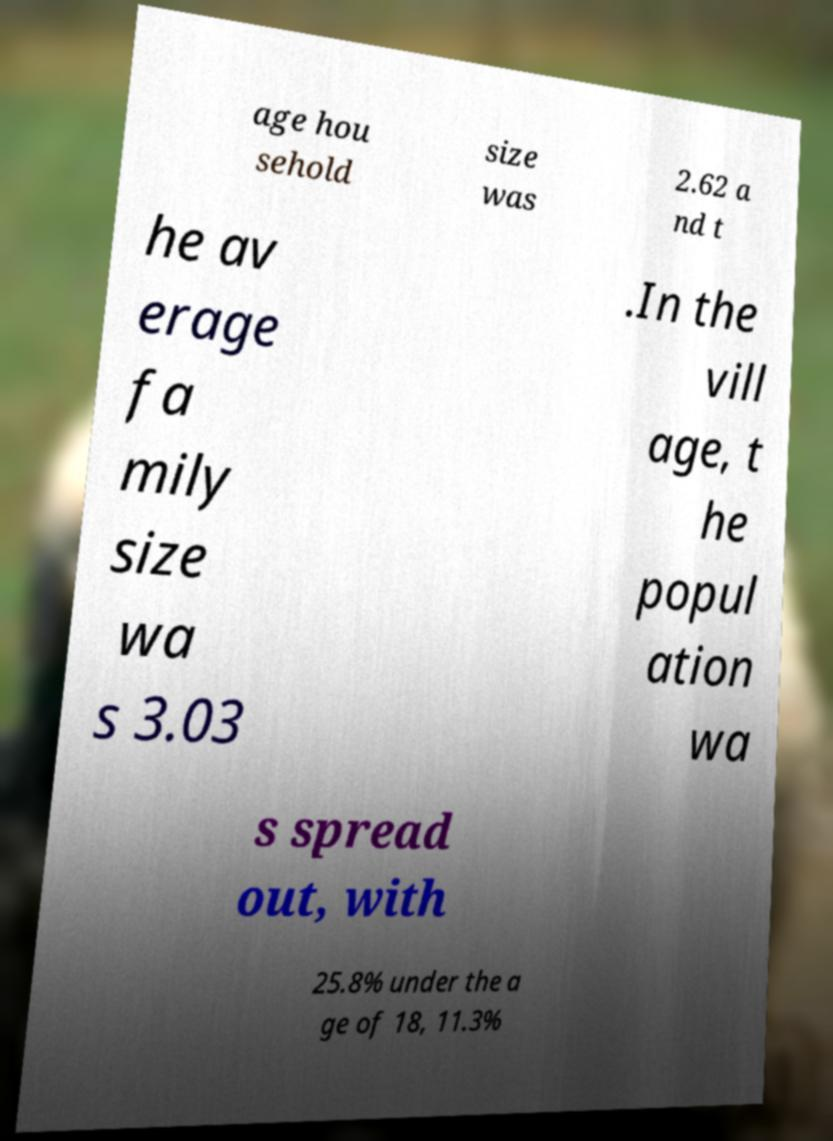Could you extract and type out the text from this image? age hou sehold size was 2.62 a nd t he av erage fa mily size wa s 3.03 .In the vill age, t he popul ation wa s spread out, with 25.8% under the a ge of 18, 11.3% 